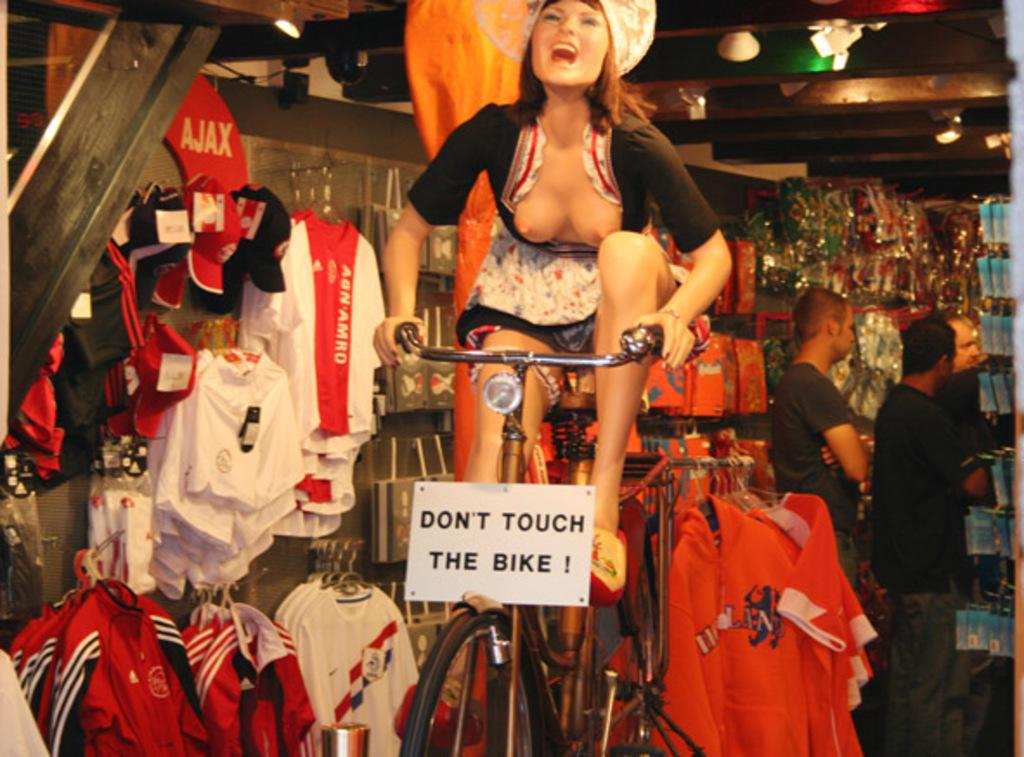Who is the main subject in the image? There is a woman in the image. What is the woman doing in the image? The woman is sitting on a cycle. What can be seen in the background of the image? There are clothes and people visible in the background of the image. What type of toe is the woman using to pedal the cycle in the image? The image does not show the woman's toes or how she is pedaling the cycle, so it cannot be determined from the image. 